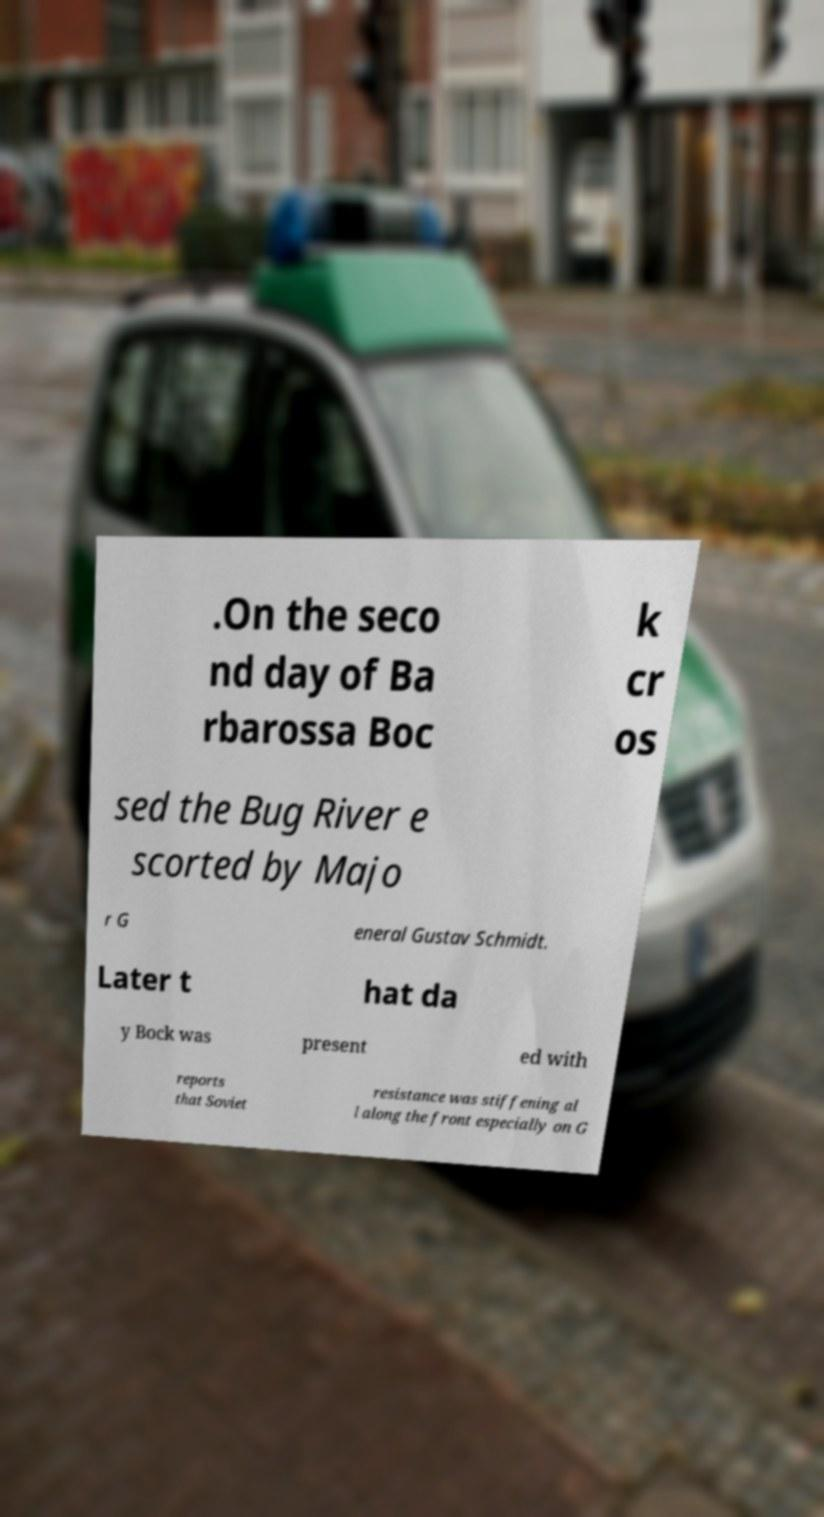Can you accurately transcribe the text from the provided image for me? .On the seco nd day of Ba rbarossa Boc k cr os sed the Bug River e scorted by Majo r G eneral Gustav Schmidt. Later t hat da y Bock was present ed with reports that Soviet resistance was stiffening al l along the front especially on G 